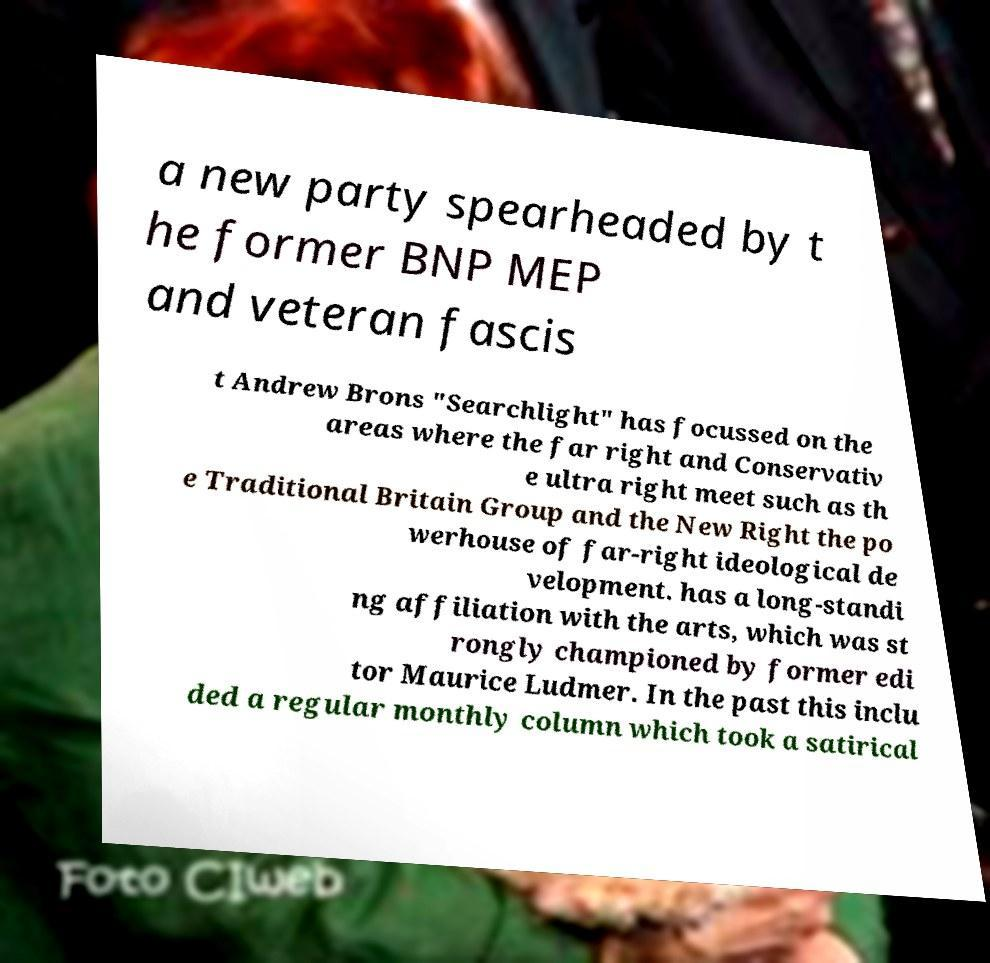There's text embedded in this image that I need extracted. Can you transcribe it verbatim? a new party spearheaded by t he former BNP MEP and veteran fascis t Andrew Brons "Searchlight" has focussed on the areas where the far right and Conservativ e ultra right meet such as th e Traditional Britain Group and the New Right the po werhouse of far-right ideological de velopment. has a long-standi ng affiliation with the arts, which was st rongly championed by former edi tor Maurice Ludmer. In the past this inclu ded a regular monthly column which took a satirical 